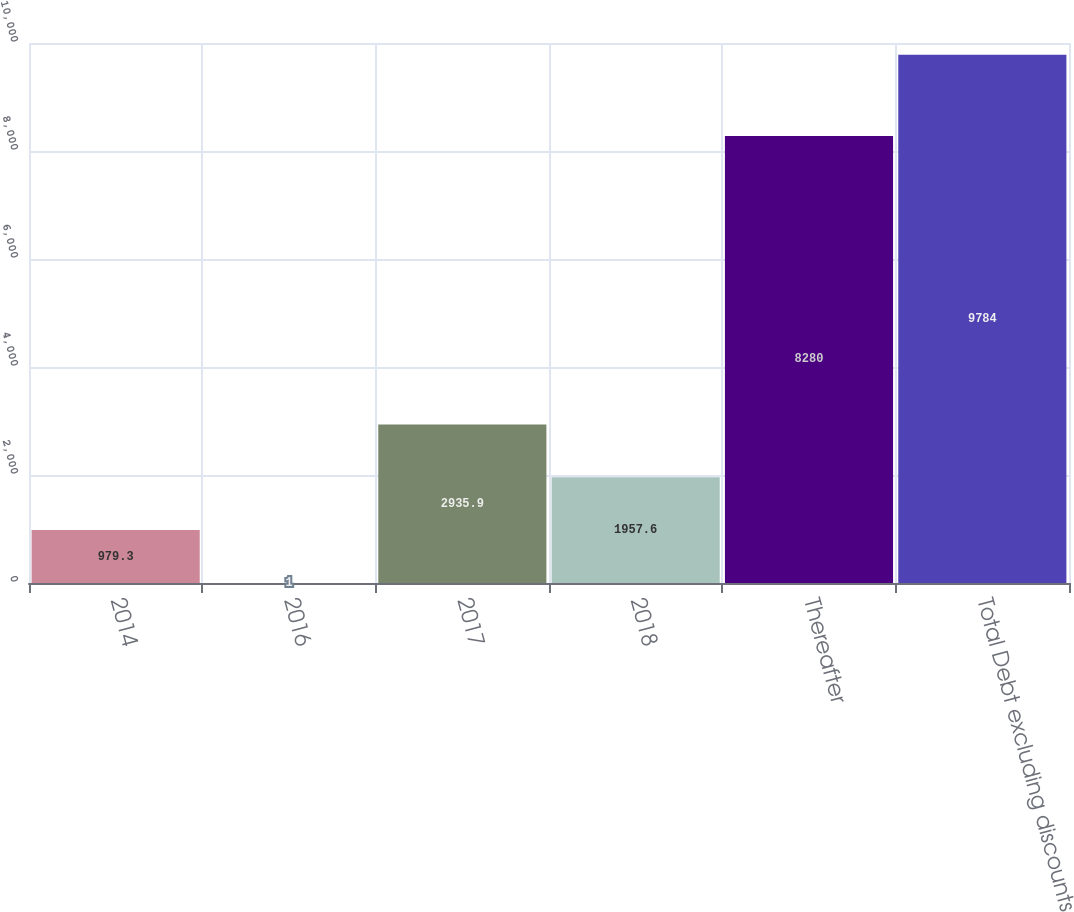Convert chart. <chart><loc_0><loc_0><loc_500><loc_500><bar_chart><fcel>2014<fcel>2016<fcel>2017<fcel>2018<fcel>Thereafter<fcel>Total Debt excluding discounts<nl><fcel>979.3<fcel>1<fcel>2935.9<fcel>1957.6<fcel>8280<fcel>9784<nl></chart> 